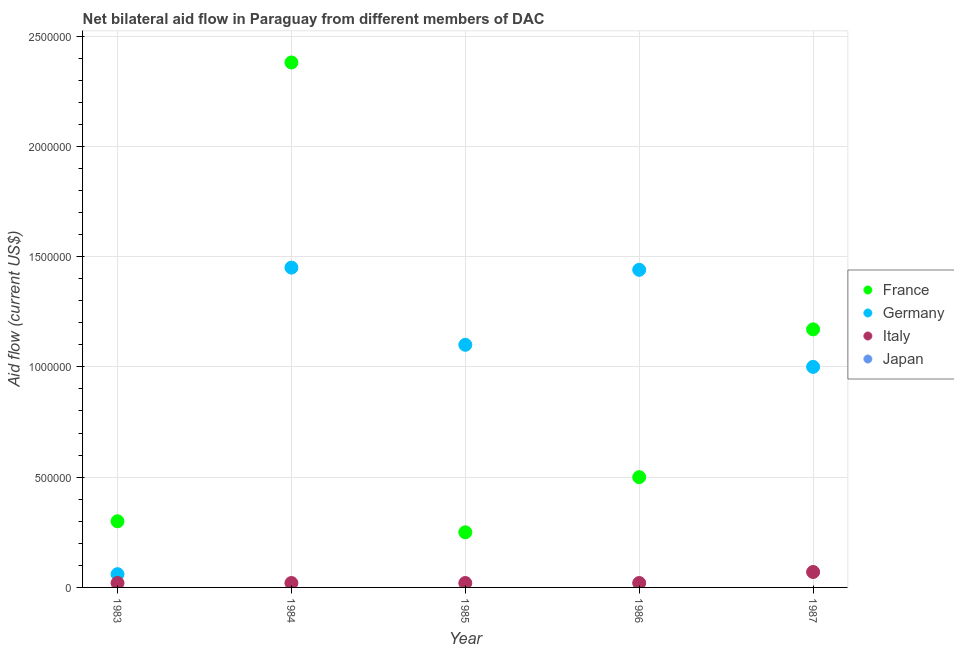How many different coloured dotlines are there?
Provide a short and direct response. 3. What is the amount of aid given by france in 1987?
Provide a short and direct response. 1.17e+06. Across all years, what is the maximum amount of aid given by italy?
Give a very brief answer. 7.00e+04. Across all years, what is the minimum amount of aid given by france?
Keep it short and to the point. 2.50e+05. In which year was the amount of aid given by germany maximum?
Make the answer very short. 1984. What is the total amount of aid given by japan in the graph?
Your response must be concise. 0. What is the difference between the amount of aid given by italy in 1983 and that in 1987?
Offer a very short reply. -5.00e+04. What is the difference between the amount of aid given by italy in 1985 and the amount of aid given by france in 1984?
Provide a succinct answer. -2.36e+06. In the year 1983, what is the difference between the amount of aid given by france and amount of aid given by germany?
Provide a succinct answer. 2.40e+05. What is the ratio of the amount of aid given by germany in 1983 to that in 1984?
Make the answer very short. 0.04. What is the difference between the highest and the lowest amount of aid given by germany?
Give a very brief answer. 1.39e+06. In how many years, is the amount of aid given by japan greater than the average amount of aid given by japan taken over all years?
Your response must be concise. 0. Is the amount of aid given by france strictly greater than the amount of aid given by italy over the years?
Provide a short and direct response. Yes. How many dotlines are there?
Your answer should be very brief. 3. How many years are there in the graph?
Offer a terse response. 5. Where does the legend appear in the graph?
Make the answer very short. Center right. How many legend labels are there?
Give a very brief answer. 4. What is the title of the graph?
Give a very brief answer. Net bilateral aid flow in Paraguay from different members of DAC. What is the label or title of the X-axis?
Your answer should be compact. Year. What is the Aid flow (current US$) of France in 1983?
Your answer should be very brief. 3.00e+05. What is the Aid flow (current US$) of France in 1984?
Make the answer very short. 2.38e+06. What is the Aid flow (current US$) of Germany in 1984?
Your answer should be compact. 1.45e+06. What is the Aid flow (current US$) of Italy in 1984?
Ensure brevity in your answer.  2.00e+04. What is the Aid flow (current US$) of Japan in 1984?
Give a very brief answer. 0. What is the Aid flow (current US$) in Germany in 1985?
Keep it short and to the point. 1.10e+06. What is the Aid flow (current US$) in Japan in 1985?
Ensure brevity in your answer.  0. What is the Aid flow (current US$) of Germany in 1986?
Make the answer very short. 1.44e+06. What is the Aid flow (current US$) in Japan in 1986?
Offer a very short reply. 0. What is the Aid flow (current US$) in France in 1987?
Your response must be concise. 1.17e+06. What is the Aid flow (current US$) in Italy in 1987?
Keep it short and to the point. 7.00e+04. Across all years, what is the maximum Aid flow (current US$) in France?
Give a very brief answer. 2.38e+06. Across all years, what is the maximum Aid flow (current US$) of Germany?
Provide a short and direct response. 1.45e+06. Across all years, what is the minimum Aid flow (current US$) of Germany?
Keep it short and to the point. 6.00e+04. Across all years, what is the minimum Aid flow (current US$) of Italy?
Provide a short and direct response. 2.00e+04. What is the total Aid flow (current US$) in France in the graph?
Provide a succinct answer. 4.60e+06. What is the total Aid flow (current US$) in Germany in the graph?
Keep it short and to the point. 5.05e+06. What is the total Aid flow (current US$) of Japan in the graph?
Your answer should be very brief. 0. What is the difference between the Aid flow (current US$) in France in 1983 and that in 1984?
Keep it short and to the point. -2.08e+06. What is the difference between the Aid flow (current US$) in Germany in 1983 and that in 1984?
Your answer should be compact. -1.39e+06. What is the difference between the Aid flow (current US$) in Germany in 1983 and that in 1985?
Provide a short and direct response. -1.04e+06. What is the difference between the Aid flow (current US$) of Germany in 1983 and that in 1986?
Your response must be concise. -1.38e+06. What is the difference between the Aid flow (current US$) of Italy in 1983 and that in 1986?
Give a very brief answer. 0. What is the difference between the Aid flow (current US$) of France in 1983 and that in 1987?
Give a very brief answer. -8.70e+05. What is the difference between the Aid flow (current US$) in Germany in 1983 and that in 1987?
Offer a terse response. -9.40e+05. What is the difference between the Aid flow (current US$) in Italy in 1983 and that in 1987?
Make the answer very short. -5.00e+04. What is the difference between the Aid flow (current US$) in France in 1984 and that in 1985?
Keep it short and to the point. 2.13e+06. What is the difference between the Aid flow (current US$) in Italy in 1984 and that in 1985?
Offer a very short reply. 0. What is the difference between the Aid flow (current US$) of France in 1984 and that in 1986?
Keep it short and to the point. 1.88e+06. What is the difference between the Aid flow (current US$) in Germany in 1984 and that in 1986?
Offer a very short reply. 10000. What is the difference between the Aid flow (current US$) in Italy in 1984 and that in 1986?
Provide a short and direct response. 0. What is the difference between the Aid flow (current US$) of France in 1984 and that in 1987?
Provide a succinct answer. 1.21e+06. What is the difference between the Aid flow (current US$) in Germany in 1984 and that in 1987?
Offer a terse response. 4.50e+05. What is the difference between the Aid flow (current US$) of Germany in 1985 and that in 1986?
Offer a terse response. -3.40e+05. What is the difference between the Aid flow (current US$) of Italy in 1985 and that in 1986?
Your answer should be compact. 0. What is the difference between the Aid flow (current US$) of France in 1985 and that in 1987?
Your answer should be very brief. -9.20e+05. What is the difference between the Aid flow (current US$) of Germany in 1985 and that in 1987?
Keep it short and to the point. 1.00e+05. What is the difference between the Aid flow (current US$) in Italy in 1985 and that in 1987?
Provide a short and direct response. -5.00e+04. What is the difference between the Aid flow (current US$) of France in 1986 and that in 1987?
Give a very brief answer. -6.70e+05. What is the difference between the Aid flow (current US$) in France in 1983 and the Aid flow (current US$) in Germany in 1984?
Make the answer very short. -1.15e+06. What is the difference between the Aid flow (current US$) in France in 1983 and the Aid flow (current US$) in Germany in 1985?
Your answer should be compact. -8.00e+05. What is the difference between the Aid flow (current US$) in France in 1983 and the Aid flow (current US$) in Germany in 1986?
Your response must be concise. -1.14e+06. What is the difference between the Aid flow (current US$) of France in 1983 and the Aid flow (current US$) of Germany in 1987?
Ensure brevity in your answer.  -7.00e+05. What is the difference between the Aid flow (current US$) in France in 1983 and the Aid flow (current US$) in Italy in 1987?
Offer a terse response. 2.30e+05. What is the difference between the Aid flow (current US$) of France in 1984 and the Aid flow (current US$) of Germany in 1985?
Offer a terse response. 1.28e+06. What is the difference between the Aid flow (current US$) of France in 1984 and the Aid flow (current US$) of Italy in 1985?
Provide a short and direct response. 2.36e+06. What is the difference between the Aid flow (current US$) of Germany in 1984 and the Aid flow (current US$) of Italy in 1985?
Provide a succinct answer. 1.43e+06. What is the difference between the Aid flow (current US$) in France in 1984 and the Aid flow (current US$) in Germany in 1986?
Provide a short and direct response. 9.40e+05. What is the difference between the Aid flow (current US$) in France in 1984 and the Aid flow (current US$) in Italy in 1986?
Offer a very short reply. 2.36e+06. What is the difference between the Aid flow (current US$) in Germany in 1984 and the Aid flow (current US$) in Italy in 1986?
Provide a succinct answer. 1.43e+06. What is the difference between the Aid flow (current US$) of France in 1984 and the Aid flow (current US$) of Germany in 1987?
Provide a short and direct response. 1.38e+06. What is the difference between the Aid flow (current US$) in France in 1984 and the Aid flow (current US$) in Italy in 1987?
Ensure brevity in your answer.  2.31e+06. What is the difference between the Aid flow (current US$) of Germany in 1984 and the Aid flow (current US$) of Italy in 1987?
Offer a very short reply. 1.38e+06. What is the difference between the Aid flow (current US$) in France in 1985 and the Aid flow (current US$) in Germany in 1986?
Make the answer very short. -1.19e+06. What is the difference between the Aid flow (current US$) in Germany in 1985 and the Aid flow (current US$) in Italy in 1986?
Ensure brevity in your answer.  1.08e+06. What is the difference between the Aid flow (current US$) in France in 1985 and the Aid flow (current US$) in Germany in 1987?
Your answer should be compact. -7.50e+05. What is the difference between the Aid flow (current US$) of France in 1985 and the Aid flow (current US$) of Italy in 1987?
Keep it short and to the point. 1.80e+05. What is the difference between the Aid flow (current US$) in Germany in 1985 and the Aid flow (current US$) in Italy in 1987?
Offer a very short reply. 1.03e+06. What is the difference between the Aid flow (current US$) of France in 1986 and the Aid flow (current US$) of Germany in 1987?
Your answer should be compact. -5.00e+05. What is the difference between the Aid flow (current US$) of Germany in 1986 and the Aid flow (current US$) of Italy in 1987?
Your response must be concise. 1.37e+06. What is the average Aid flow (current US$) of France per year?
Provide a succinct answer. 9.20e+05. What is the average Aid flow (current US$) of Germany per year?
Keep it short and to the point. 1.01e+06. What is the average Aid flow (current US$) of Italy per year?
Provide a succinct answer. 3.00e+04. What is the average Aid flow (current US$) in Japan per year?
Offer a terse response. 0. In the year 1984, what is the difference between the Aid flow (current US$) in France and Aid flow (current US$) in Germany?
Provide a succinct answer. 9.30e+05. In the year 1984, what is the difference between the Aid flow (current US$) in France and Aid flow (current US$) in Italy?
Make the answer very short. 2.36e+06. In the year 1984, what is the difference between the Aid flow (current US$) of Germany and Aid flow (current US$) of Italy?
Keep it short and to the point. 1.43e+06. In the year 1985, what is the difference between the Aid flow (current US$) of France and Aid flow (current US$) of Germany?
Your answer should be compact. -8.50e+05. In the year 1985, what is the difference between the Aid flow (current US$) in Germany and Aid flow (current US$) in Italy?
Your answer should be compact. 1.08e+06. In the year 1986, what is the difference between the Aid flow (current US$) in France and Aid flow (current US$) in Germany?
Provide a short and direct response. -9.40e+05. In the year 1986, what is the difference between the Aid flow (current US$) of Germany and Aid flow (current US$) of Italy?
Provide a short and direct response. 1.42e+06. In the year 1987, what is the difference between the Aid flow (current US$) of France and Aid flow (current US$) of Germany?
Provide a succinct answer. 1.70e+05. In the year 1987, what is the difference between the Aid flow (current US$) in France and Aid flow (current US$) in Italy?
Your response must be concise. 1.10e+06. In the year 1987, what is the difference between the Aid flow (current US$) of Germany and Aid flow (current US$) of Italy?
Provide a succinct answer. 9.30e+05. What is the ratio of the Aid flow (current US$) of France in 1983 to that in 1984?
Your response must be concise. 0.13. What is the ratio of the Aid flow (current US$) in Germany in 1983 to that in 1984?
Make the answer very short. 0.04. What is the ratio of the Aid flow (current US$) in Italy in 1983 to that in 1984?
Your response must be concise. 1. What is the ratio of the Aid flow (current US$) in Germany in 1983 to that in 1985?
Keep it short and to the point. 0.05. What is the ratio of the Aid flow (current US$) in France in 1983 to that in 1986?
Provide a short and direct response. 0.6. What is the ratio of the Aid flow (current US$) in Germany in 1983 to that in 1986?
Give a very brief answer. 0.04. What is the ratio of the Aid flow (current US$) of France in 1983 to that in 1987?
Keep it short and to the point. 0.26. What is the ratio of the Aid flow (current US$) of Germany in 1983 to that in 1987?
Make the answer very short. 0.06. What is the ratio of the Aid flow (current US$) in Italy in 1983 to that in 1987?
Your answer should be very brief. 0.29. What is the ratio of the Aid flow (current US$) in France in 1984 to that in 1985?
Make the answer very short. 9.52. What is the ratio of the Aid flow (current US$) of Germany in 1984 to that in 1985?
Keep it short and to the point. 1.32. What is the ratio of the Aid flow (current US$) in Italy in 1984 to that in 1985?
Offer a very short reply. 1. What is the ratio of the Aid flow (current US$) in France in 1984 to that in 1986?
Provide a short and direct response. 4.76. What is the ratio of the Aid flow (current US$) of Germany in 1984 to that in 1986?
Ensure brevity in your answer.  1.01. What is the ratio of the Aid flow (current US$) of France in 1984 to that in 1987?
Give a very brief answer. 2.03. What is the ratio of the Aid flow (current US$) in Germany in 1984 to that in 1987?
Your answer should be very brief. 1.45. What is the ratio of the Aid flow (current US$) in Italy in 1984 to that in 1987?
Provide a succinct answer. 0.29. What is the ratio of the Aid flow (current US$) of Germany in 1985 to that in 1986?
Offer a terse response. 0.76. What is the ratio of the Aid flow (current US$) of Italy in 1985 to that in 1986?
Your response must be concise. 1. What is the ratio of the Aid flow (current US$) in France in 1985 to that in 1987?
Make the answer very short. 0.21. What is the ratio of the Aid flow (current US$) in Italy in 1985 to that in 1987?
Provide a short and direct response. 0.29. What is the ratio of the Aid flow (current US$) in France in 1986 to that in 1987?
Make the answer very short. 0.43. What is the ratio of the Aid flow (current US$) of Germany in 1986 to that in 1987?
Your response must be concise. 1.44. What is the ratio of the Aid flow (current US$) of Italy in 1986 to that in 1987?
Your response must be concise. 0.29. What is the difference between the highest and the second highest Aid flow (current US$) of France?
Ensure brevity in your answer.  1.21e+06. What is the difference between the highest and the second highest Aid flow (current US$) of Germany?
Keep it short and to the point. 10000. What is the difference between the highest and the second highest Aid flow (current US$) in Italy?
Offer a terse response. 5.00e+04. What is the difference between the highest and the lowest Aid flow (current US$) of France?
Your answer should be compact. 2.13e+06. What is the difference between the highest and the lowest Aid flow (current US$) of Germany?
Offer a terse response. 1.39e+06. 